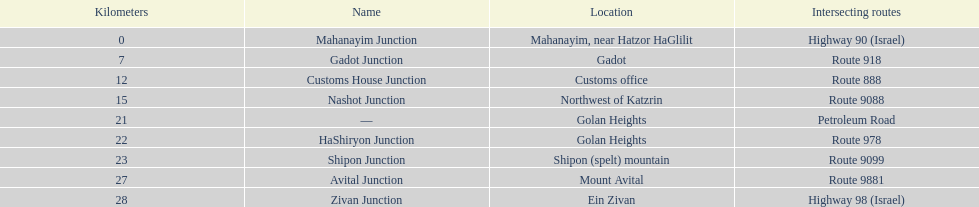What is the final intersection on highway 91? Zivan Junction. 